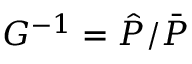<formula> <loc_0><loc_0><loc_500><loc_500>G ^ { - 1 } = \hat { P } / \bar { P }</formula> 